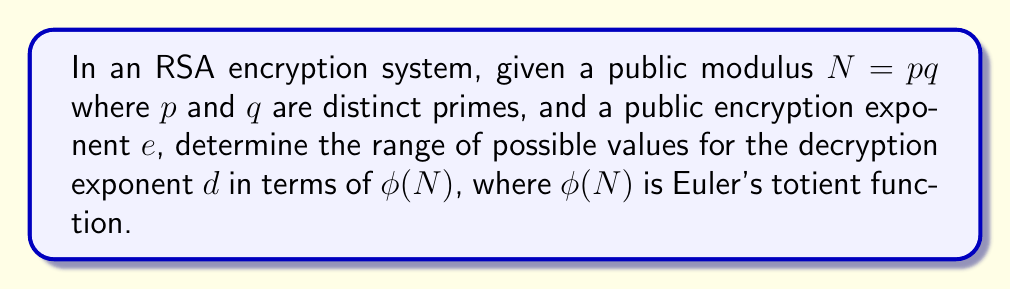Provide a solution to this math problem. 1) In RSA, the decryption exponent $d$ must satisfy the congruence:

   $ed \equiv 1 \pmod{\phi(N)}$

2) This congruence can be written as an equation:

   $ed = 1 + k\phi(N)$, where $k$ is some integer.

3) Solving for $d$:

   $d = \frac{1 + k\phi(N)}{e}$

4) For $d$ to be a valid decryption exponent, it must be a positive integer. Therefore:

   $1 + k\phi(N) > 0$ and $1 + k\phi(N)$ must be divisible by $e$

5) The smallest positive value for $d$ occurs when $k = 1$:

   $d_{min} = \frac{1 + \phi(N)}{e}$

6) The largest value for $d$ that maintains the security of RSA is $\phi(N) - 1$. This is because using $d \geq \phi(N)$ would be equivalent to using $d \bmod \phi(N)$, which is smaller.

7) Therefore, the range of possible values for $d$ is:

   $\frac{1 + \phi(N)}{e} \leq d < \phi(N)$
Answer: $\frac{1 + \phi(N)}{e} \leq d < \phi(N)$ 